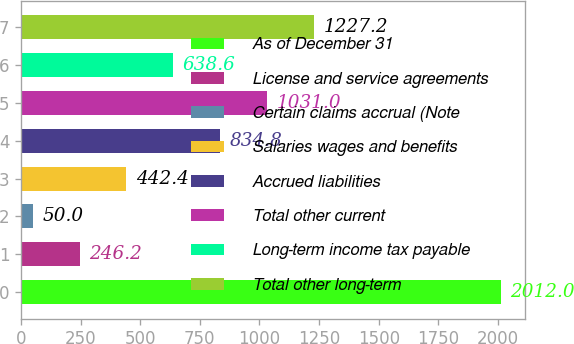<chart> <loc_0><loc_0><loc_500><loc_500><bar_chart><fcel>As of December 31<fcel>License and service agreements<fcel>Certain claims accrual (Note<fcel>Salaries wages and benefits<fcel>Accrued liabilities<fcel>Total other current<fcel>Long-term income tax payable<fcel>Total other long-term<nl><fcel>2012<fcel>246.2<fcel>50<fcel>442.4<fcel>834.8<fcel>1031<fcel>638.6<fcel>1227.2<nl></chart> 